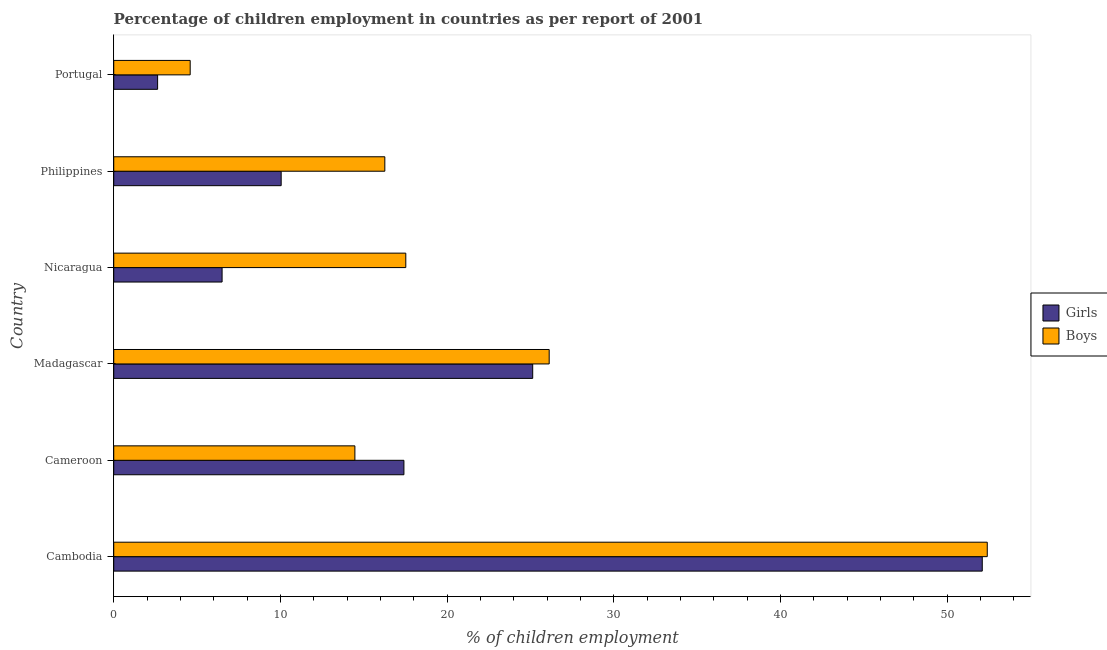How many groups of bars are there?
Offer a terse response. 6. Are the number of bars per tick equal to the number of legend labels?
Your response must be concise. Yes. How many bars are there on the 5th tick from the top?
Ensure brevity in your answer.  2. What is the label of the 6th group of bars from the top?
Ensure brevity in your answer.  Cambodia. What is the percentage of employed boys in Cambodia?
Make the answer very short. 52.4. Across all countries, what is the maximum percentage of employed girls?
Your answer should be very brief. 52.1. Across all countries, what is the minimum percentage of employed boys?
Offer a very short reply. 4.59. In which country was the percentage of employed girls maximum?
Your response must be concise. Cambodia. In which country was the percentage of employed boys minimum?
Your answer should be very brief. Portugal. What is the total percentage of employed boys in the graph?
Your response must be concise. 131.35. What is the difference between the percentage of employed boys in Cameroon and that in Madagascar?
Ensure brevity in your answer.  -11.65. What is the difference between the percentage of employed girls in Nicaragua and the percentage of employed boys in Portugal?
Offer a very short reply. 1.91. What is the average percentage of employed boys per country?
Your response must be concise. 21.89. What is the ratio of the percentage of employed girls in Madagascar to that in Portugal?
Make the answer very short. 9.55. Is the percentage of employed girls in Cambodia less than that in Philippines?
Your answer should be very brief. No. Is the difference between the percentage of employed boys in Cambodia and Portugal greater than the difference between the percentage of employed girls in Cambodia and Portugal?
Your answer should be compact. No. What is the difference between the highest and the second highest percentage of employed boys?
Your answer should be very brief. 26.28. What is the difference between the highest and the lowest percentage of employed girls?
Make the answer very short. 49.47. In how many countries, is the percentage of employed boys greater than the average percentage of employed boys taken over all countries?
Your answer should be very brief. 2. Is the sum of the percentage of employed girls in Cambodia and Cameroon greater than the maximum percentage of employed boys across all countries?
Ensure brevity in your answer.  Yes. What does the 2nd bar from the top in Cambodia represents?
Offer a very short reply. Girls. What does the 2nd bar from the bottom in Cameroon represents?
Make the answer very short. Boys. What is the difference between two consecutive major ticks on the X-axis?
Your answer should be compact. 10. Are the values on the major ticks of X-axis written in scientific E-notation?
Your response must be concise. No. How many legend labels are there?
Offer a terse response. 2. What is the title of the graph?
Your answer should be compact. Percentage of children employment in countries as per report of 2001. Does "Not attending school" appear as one of the legend labels in the graph?
Provide a short and direct response. No. What is the label or title of the X-axis?
Provide a succinct answer. % of children employment. What is the label or title of the Y-axis?
Ensure brevity in your answer.  Country. What is the % of children employment in Girls in Cambodia?
Offer a very short reply. 52.1. What is the % of children employment in Boys in Cambodia?
Your answer should be very brief. 52.4. What is the % of children employment of Girls in Cameroon?
Make the answer very short. 17.41. What is the % of children employment of Boys in Cameroon?
Provide a short and direct response. 14.47. What is the % of children employment in Girls in Madagascar?
Your answer should be very brief. 25.13. What is the % of children employment in Boys in Madagascar?
Give a very brief answer. 26.12. What is the % of children employment of Girls in Nicaragua?
Offer a very short reply. 6.5. What is the % of children employment in Boys in Nicaragua?
Make the answer very short. 17.52. What is the % of children employment in Girls in Philippines?
Offer a terse response. 10.04. What is the % of children employment of Boys in Philippines?
Offer a very short reply. 16.26. What is the % of children employment in Girls in Portugal?
Offer a very short reply. 2.63. What is the % of children employment of Boys in Portugal?
Provide a short and direct response. 4.59. Across all countries, what is the maximum % of children employment in Girls?
Offer a very short reply. 52.1. Across all countries, what is the maximum % of children employment in Boys?
Your answer should be very brief. 52.4. Across all countries, what is the minimum % of children employment of Girls?
Provide a short and direct response. 2.63. Across all countries, what is the minimum % of children employment of Boys?
Your answer should be compact. 4.59. What is the total % of children employment of Girls in the graph?
Offer a terse response. 113.81. What is the total % of children employment in Boys in the graph?
Your response must be concise. 131.35. What is the difference between the % of children employment in Girls in Cambodia and that in Cameroon?
Your answer should be very brief. 34.69. What is the difference between the % of children employment of Boys in Cambodia and that in Cameroon?
Your answer should be very brief. 37.93. What is the difference between the % of children employment in Girls in Cambodia and that in Madagascar?
Keep it short and to the point. 26.97. What is the difference between the % of children employment of Boys in Cambodia and that in Madagascar?
Your answer should be compact. 26.28. What is the difference between the % of children employment of Girls in Cambodia and that in Nicaragua?
Ensure brevity in your answer.  45.6. What is the difference between the % of children employment of Boys in Cambodia and that in Nicaragua?
Your answer should be compact. 34.88. What is the difference between the % of children employment of Girls in Cambodia and that in Philippines?
Keep it short and to the point. 42.06. What is the difference between the % of children employment in Boys in Cambodia and that in Philippines?
Make the answer very short. 36.14. What is the difference between the % of children employment of Girls in Cambodia and that in Portugal?
Your answer should be compact. 49.47. What is the difference between the % of children employment in Boys in Cambodia and that in Portugal?
Make the answer very short. 47.81. What is the difference between the % of children employment of Girls in Cameroon and that in Madagascar?
Make the answer very short. -7.73. What is the difference between the % of children employment of Boys in Cameroon and that in Madagascar?
Provide a short and direct response. -11.65. What is the difference between the % of children employment of Girls in Cameroon and that in Nicaragua?
Make the answer very short. 10.91. What is the difference between the % of children employment in Boys in Cameroon and that in Nicaragua?
Provide a short and direct response. -3.05. What is the difference between the % of children employment in Girls in Cameroon and that in Philippines?
Keep it short and to the point. 7.36. What is the difference between the % of children employment in Boys in Cameroon and that in Philippines?
Your answer should be very brief. -1.8. What is the difference between the % of children employment in Girls in Cameroon and that in Portugal?
Offer a terse response. 14.78. What is the difference between the % of children employment of Boys in Cameroon and that in Portugal?
Make the answer very short. 9.88. What is the difference between the % of children employment of Girls in Madagascar and that in Nicaragua?
Provide a short and direct response. 18.63. What is the difference between the % of children employment of Boys in Madagascar and that in Nicaragua?
Provide a succinct answer. 8.6. What is the difference between the % of children employment in Girls in Madagascar and that in Philippines?
Your answer should be compact. 15.09. What is the difference between the % of children employment in Boys in Madagascar and that in Philippines?
Make the answer very short. 9.86. What is the difference between the % of children employment in Girls in Madagascar and that in Portugal?
Your answer should be compact. 22.5. What is the difference between the % of children employment in Boys in Madagascar and that in Portugal?
Provide a succinct answer. 21.53. What is the difference between the % of children employment of Girls in Nicaragua and that in Philippines?
Provide a short and direct response. -3.54. What is the difference between the % of children employment of Boys in Nicaragua and that in Philippines?
Keep it short and to the point. 1.26. What is the difference between the % of children employment of Girls in Nicaragua and that in Portugal?
Offer a terse response. 3.87. What is the difference between the % of children employment in Boys in Nicaragua and that in Portugal?
Your answer should be compact. 12.93. What is the difference between the % of children employment of Girls in Philippines and that in Portugal?
Your answer should be very brief. 7.41. What is the difference between the % of children employment in Boys in Philippines and that in Portugal?
Give a very brief answer. 11.68. What is the difference between the % of children employment of Girls in Cambodia and the % of children employment of Boys in Cameroon?
Make the answer very short. 37.63. What is the difference between the % of children employment of Girls in Cambodia and the % of children employment of Boys in Madagascar?
Your answer should be very brief. 25.98. What is the difference between the % of children employment of Girls in Cambodia and the % of children employment of Boys in Nicaragua?
Provide a succinct answer. 34.58. What is the difference between the % of children employment in Girls in Cambodia and the % of children employment in Boys in Philippines?
Your response must be concise. 35.84. What is the difference between the % of children employment in Girls in Cambodia and the % of children employment in Boys in Portugal?
Give a very brief answer. 47.51. What is the difference between the % of children employment in Girls in Cameroon and the % of children employment in Boys in Madagascar?
Keep it short and to the point. -8.71. What is the difference between the % of children employment of Girls in Cameroon and the % of children employment of Boys in Nicaragua?
Give a very brief answer. -0.11. What is the difference between the % of children employment in Girls in Cameroon and the % of children employment in Boys in Philippines?
Give a very brief answer. 1.14. What is the difference between the % of children employment in Girls in Cameroon and the % of children employment in Boys in Portugal?
Make the answer very short. 12.82. What is the difference between the % of children employment of Girls in Madagascar and the % of children employment of Boys in Nicaragua?
Keep it short and to the point. 7.61. What is the difference between the % of children employment in Girls in Madagascar and the % of children employment in Boys in Philippines?
Make the answer very short. 8.87. What is the difference between the % of children employment in Girls in Madagascar and the % of children employment in Boys in Portugal?
Your response must be concise. 20.55. What is the difference between the % of children employment of Girls in Nicaragua and the % of children employment of Boys in Philippines?
Offer a very short reply. -9.76. What is the difference between the % of children employment of Girls in Nicaragua and the % of children employment of Boys in Portugal?
Keep it short and to the point. 1.91. What is the difference between the % of children employment in Girls in Philippines and the % of children employment in Boys in Portugal?
Your answer should be compact. 5.46. What is the average % of children employment in Girls per country?
Keep it short and to the point. 18.97. What is the average % of children employment of Boys per country?
Make the answer very short. 21.89. What is the difference between the % of children employment of Girls and % of children employment of Boys in Cambodia?
Offer a terse response. -0.3. What is the difference between the % of children employment of Girls and % of children employment of Boys in Cameroon?
Give a very brief answer. 2.94. What is the difference between the % of children employment in Girls and % of children employment in Boys in Madagascar?
Keep it short and to the point. -0.99. What is the difference between the % of children employment in Girls and % of children employment in Boys in Nicaragua?
Ensure brevity in your answer.  -11.02. What is the difference between the % of children employment of Girls and % of children employment of Boys in Philippines?
Offer a terse response. -6.22. What is the difference between the % of children employment in Girls and % of children employment in Boys in Portugal?
Provide a succinct answer. -1.95. What is the ratio of the % of children employment in Girls in Cambodia to that in Cameroon?
Provide a short and direct response. 2.99. What is the ratio of the % of children employment of Boys in Cambodia to that in Cameroon?
Provide a succinct answer. 3.62. What is the ratio of the % of children employment of Girls in Cambodia to that in Madagascar?
Provide a short and direct response. 2.07. What is the ratio of the % of children employment in Boys in Cambodia to that in Madagascar?
Give a very brief answer. 2.01. What is the ratio of the % of children employment of Girls in Cambodia to that in Nicaragua?
Provide a succinct answer. 8.02. What is the ratio of the % of children employment of Boys in Cambodia to that in Nicaragua?
Provide a short and direct response. 2.99. What is the ratio of the % of children employment in Girls in Cambodia to that in Philippines?
Give a very brief answer. 5.19. What is the ratio of the % of children employment of Boys in Cambodia to that in Philippines?
Provide a short and direct response. 3.22. What is the ratio of the % of children employment of Girls in Cambodia to that in Portugal?
Keep it short and to the point. 19.8. What is the ratio of the % of children employment in Boys in Cambodia to that in Portugal?
Give a very brief answer. 11.43. What is the ratio of the % of children employment of Girls in Cameroon to that in Madagascar?
Your answer should be very brief. 0.69. What is the ratio of the % of children employment in Boys in Cameroon to that in Madagascar?
Provide a short and direct response. 0.55. What is the ratio of the % of children employment of Girls in Cameroon to that in Nicaragua?
Provide a short and direct response. 2.68. What is the ratio of the % of children employment in Boys in Cameroon to that in Nicaragua?
Offer a terse response. 0.83. What is the ratio of the % of children employment of Girls in Cameroon to that in Philippines?
Make the answer very short. 1.73. What is the ratio of the % of children employment in Boys in Cameroon to that in Philippines?
Give a very brief answer. 0.89. What is the ratio of the % of children employment of Girls in Cameroon to that in Portugal?
Offer a terse response. 6.61. What is the ratio of the % of children employment in Boys in Cameroon to that in Portugal?
Offer a terse response. 3.15. What is the ratio of the % of children employment of Girls in Madagascar to that in Nicaragua?
Ensure brevity in your answer.  3.87. What is the ratio of the % of children employment of Boys in Madagascar to that in Nicaragua?
Your answer should be compact. 1.49. What is the ratio of the % of children employment in Girls in Madagascar to that in Philippines?
Provide a short and direct response. 2.5. What is the ratio of the % of children employment of Boys in Madagascar to that in Philippines?
Give a very brief answer. 1.61. What is the ratio of the % of children employment in Girls in Madagascar to that in Portugal?
Your answer should be very brief. 9.55. What is the ratio of the % of children employment in Boys in Madagascar to that in Portugal?
Keep it short and to the point. 5.7. What is the ratio of the % of children employment in Girls in Nicaragua to that in Philippines?
Provide a succinct answer. 0.65. What is the ratio of the % of children employment of Boys in Nicaragua to that in Philippines?
Keep it short and to the point. 1.08. What is the ratio of the % of children employment in Girls in Nicaragua to that in Portugal?
Offer a very short reply. 2.47. What is the ratio of the % of children employment in Boys in Nicaragua to that in Portugal?
Make the answer very short. 3.82. What is the ratio of the % of children employment of Girls in Philippines to that in Portugal?
Keep it short and to the point. 3.82. What is the ratio of the % of children employment of Boys in Philippines to that in Portugal?
Keep it short and to the point. 3.55. What is the difference between the highest and the second highest % of children employment in Girls?
Offer a terse response. 26.97. What is the difference between the highest and the second highest % of children employment of Boys?
Your answer should be very brief. 26.28. What is the difference between the highest and the lowest % of children employment in Girls?
Offer a terse response. 49.47. What is the difference between the highest and the lowest % of children employment of Boys?
Your response must be concise. 47.81. 